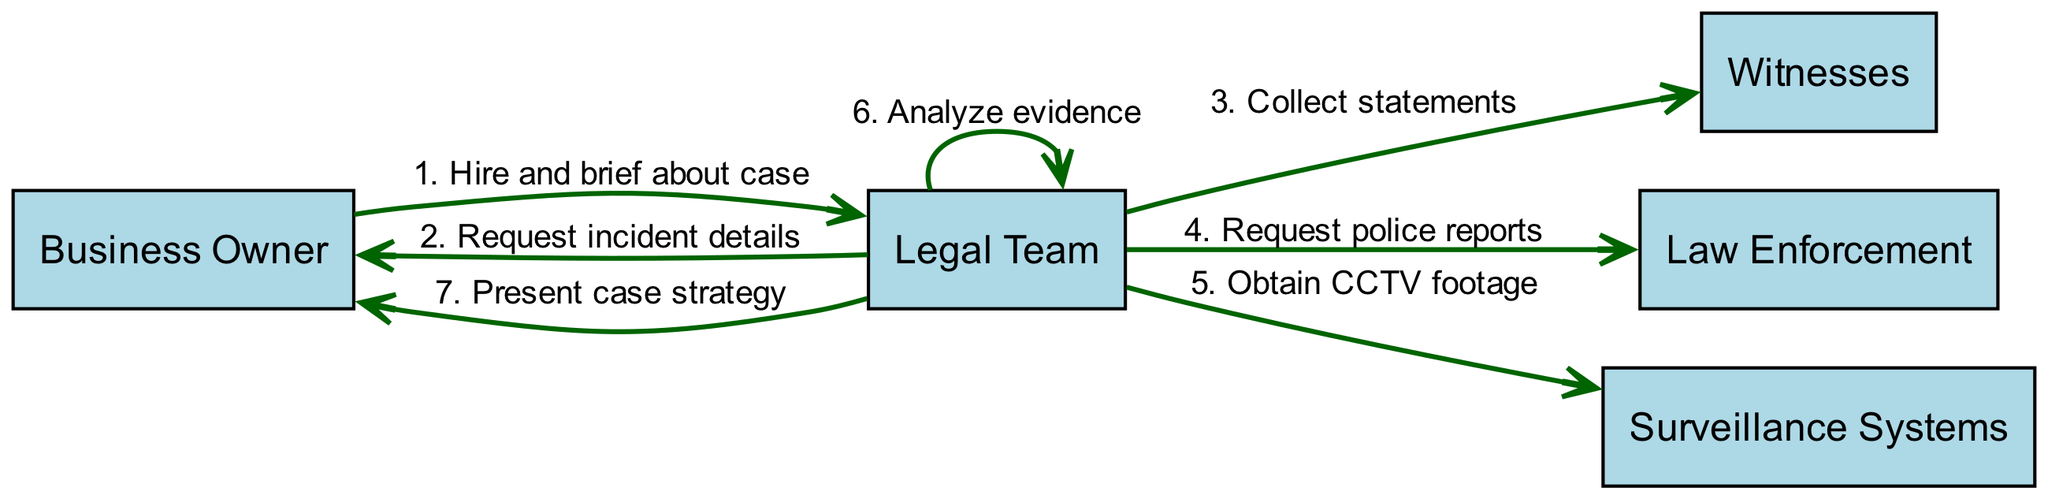What is the first action taken in the sequence? The first action is initiated by the Business Owner when she hires and briefs the Legal Team about the case. This can be found as the first entry in the sequence steps.
Answer: Hire and brief about case How many actors are in the diagram? The diagram lists five distinct actors: Business Owner, Legal Team, Witnesses, Law Enforcement, and Surveillance Systems. To find the answer, simply count the unique actors presented.
Answer: 5 Who does the Legal Team collect statements from? The action clearly indicates that the Legal Team collects statements from Witnesses, making it clear who the target of this action is.
Answer: Witnesses What is the last action performed by the Legal Team? The last action indicated in the sequence is that the Legal Team presents case strategy to the Business Owner. This can be identified as the final step in the flow.
Answer: Present case strategy How many requests does the Legal Team make? By reviewing the sequence of actions, it's clear that the Legal Team makes three requests: for incident details, police reports, and for CCTV footage. Counting these actions gives the answer.
Answer: 3 What is the role of the Surveillance Systems in the investigation? The Surveillance Systems are involved when the Legal Team obtains CCTV footage, showing their role as a source of evidence in the investigation. This is highlighted in the sequence flow.
Answer: Obtain CCTV footage Which actor is involved in analyzing evidence? The sequence clearly indicates that the Legal Team itself is responsible for analyzing evidence, as seen in the corresponding action.
Answer: Legal Team What is the relationship between the Business Owner and the Legal Team? The relationship can be described as one of hiring and briefing. The sequence starts with the Business Owner hiring the Legal Team, which establishes their primary interaction.
Answer: Hire and brief 